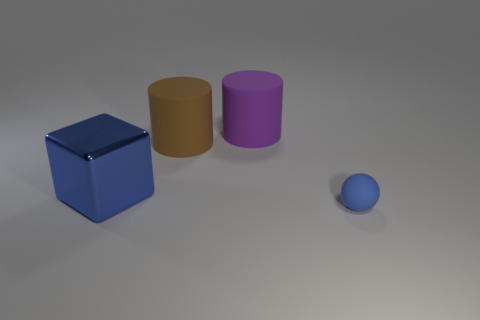There is a small thing that is the same material as the big purple cylinder; what shape is it?
Give a very brief answer. Sphere. How many other objects are there of the same shape as the purple thing?
Ensure brevity in your answer.  1. The rubber object in front of the blue object left of the object in front of the shiny block is what shape?
Your response must be concise. Sphere. How many cylinders are either big metal things or rubber objects?
Offer a very short reply. 2. There is a thing on the left side of the brown rubber object; are there any large blue blocks in front of it?
Give a very brief answer. No. Are there any other things that have the same material as the big blue cube?
Provide a short and direct response. No. Is the shape of the blue rubber object the same as the blue object that is behind the tiny blue object?
Give a very brief answer. No. How many other objects are the same size as the blue shiny thing?
Your answer should be very brief. 2. What number of cyan objects are big cubes or big matte things?
Keep it short and to the point. 0. What number of objects are behind the big brown thing and right of the big purple rubber cylinder?
Provide a succinct answer. 0. 